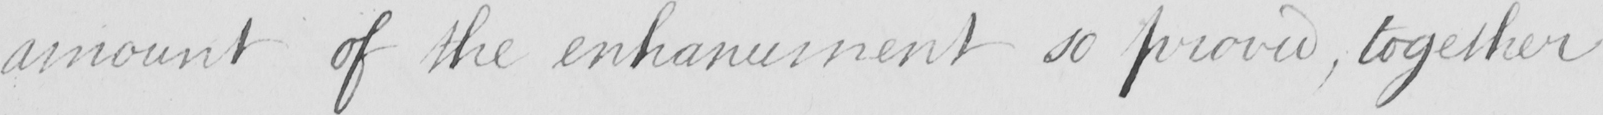Please transcribe the handwritten text in this image. amount of the enhancement so proved  , together 